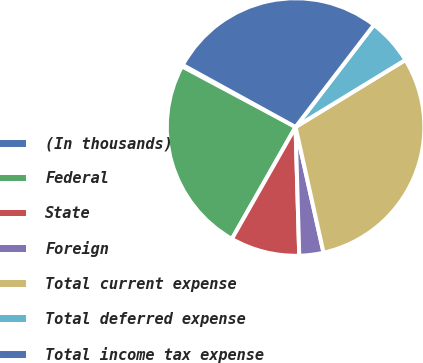<chart> <loc_0><loc_0><loc_500><loc_500><pie_chart><fcel>(In thousands)<fcel>Federal<fcel>State<fcel>Foreign<fcel>Total current expense<fcel>Total deferred expense<fcel>Total income tax expense<nl><fcel>0.2%<fcel>24.57%<fcel>8.69%<fcel>3.03%<fcel>30.24%<fcel>5.86%<fcel>27.41%<nl></chart> 